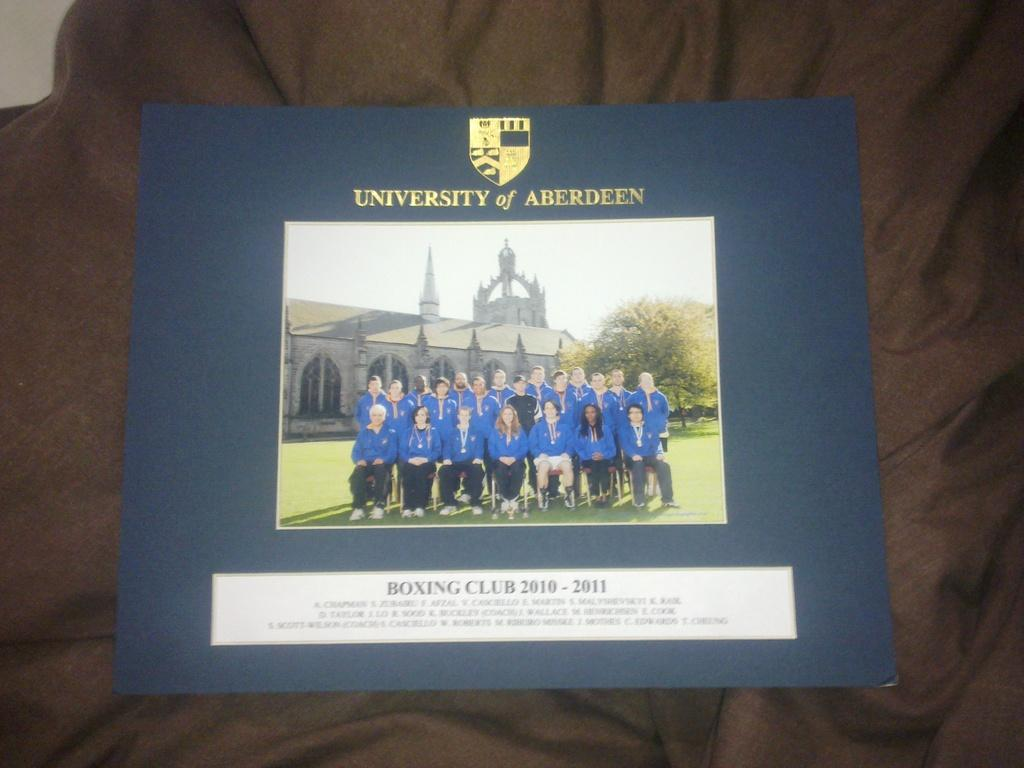<image>
Relay a brief, clear account of the picture shown. A framed photo of the University Of Aberdeen Boxing club from 2010-2011. 